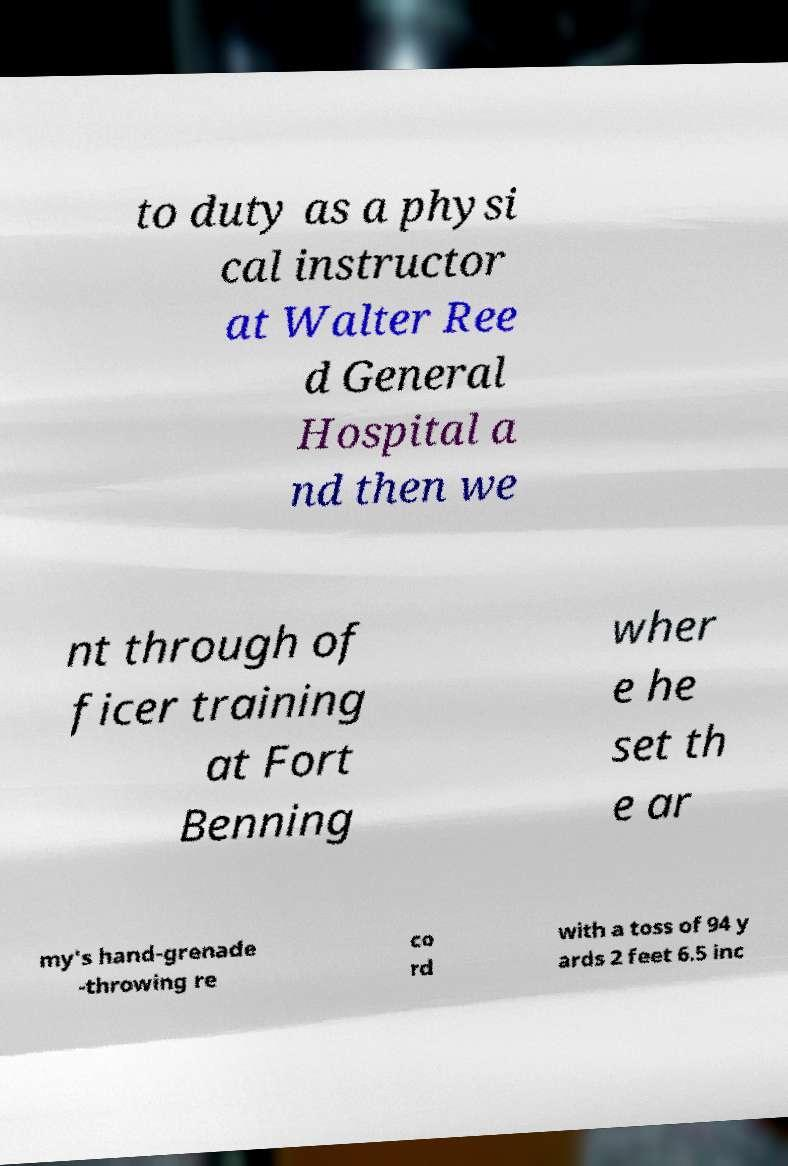Please read and relay the text visible in this image. What does it say? to duty as a physi cal instructor at Walter Ree d General Hospital a nd then we nt through of ficer training at Fort Benning wher e he set th e ar my's hand-grenade -throwing re co rd with a toss of 94 y ards 2 feet 6.5 inc 